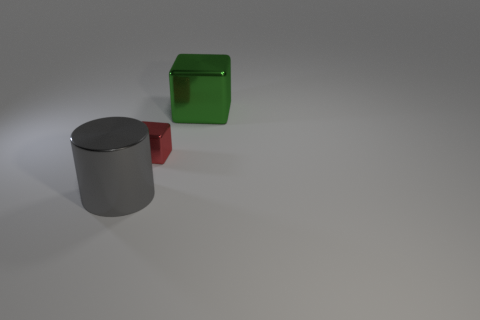Is there anything else that has the same size as the red metallic object?
Offer a terse response. No. Are there any large green blocks in front of the big gray metallic cylinder?
Give a very brief answer. No. What number of big metallic cylinders are there?
Offer a terse response. 1. There is a large metallic object in front of the tiny metallic block; how many large green metal cubes are in front of it?
Provide a short and direct response. 0. How many red objects are the same shape as the gray thing?
Your answer should be compact. 0. There is a small red thing that is in front of the green cube; is it the same shape as the big green object?
Offer a terse response. Yes. Is there a cyan matte block of the same size as the metal cylinder?
Keep it short and to the point. No. There is a green metal object; is it the same shape as the big shiny object that is in front of the small red block?
Make the answer very short. No. Is the number of large cylinders that are to the right of the green block less than the number of small shiny things?
Keep it short and to the point. Yes. Do the red shiny thing and the big green metallic object have the same shape?
Ensure brevity in your answer.  Yes. 